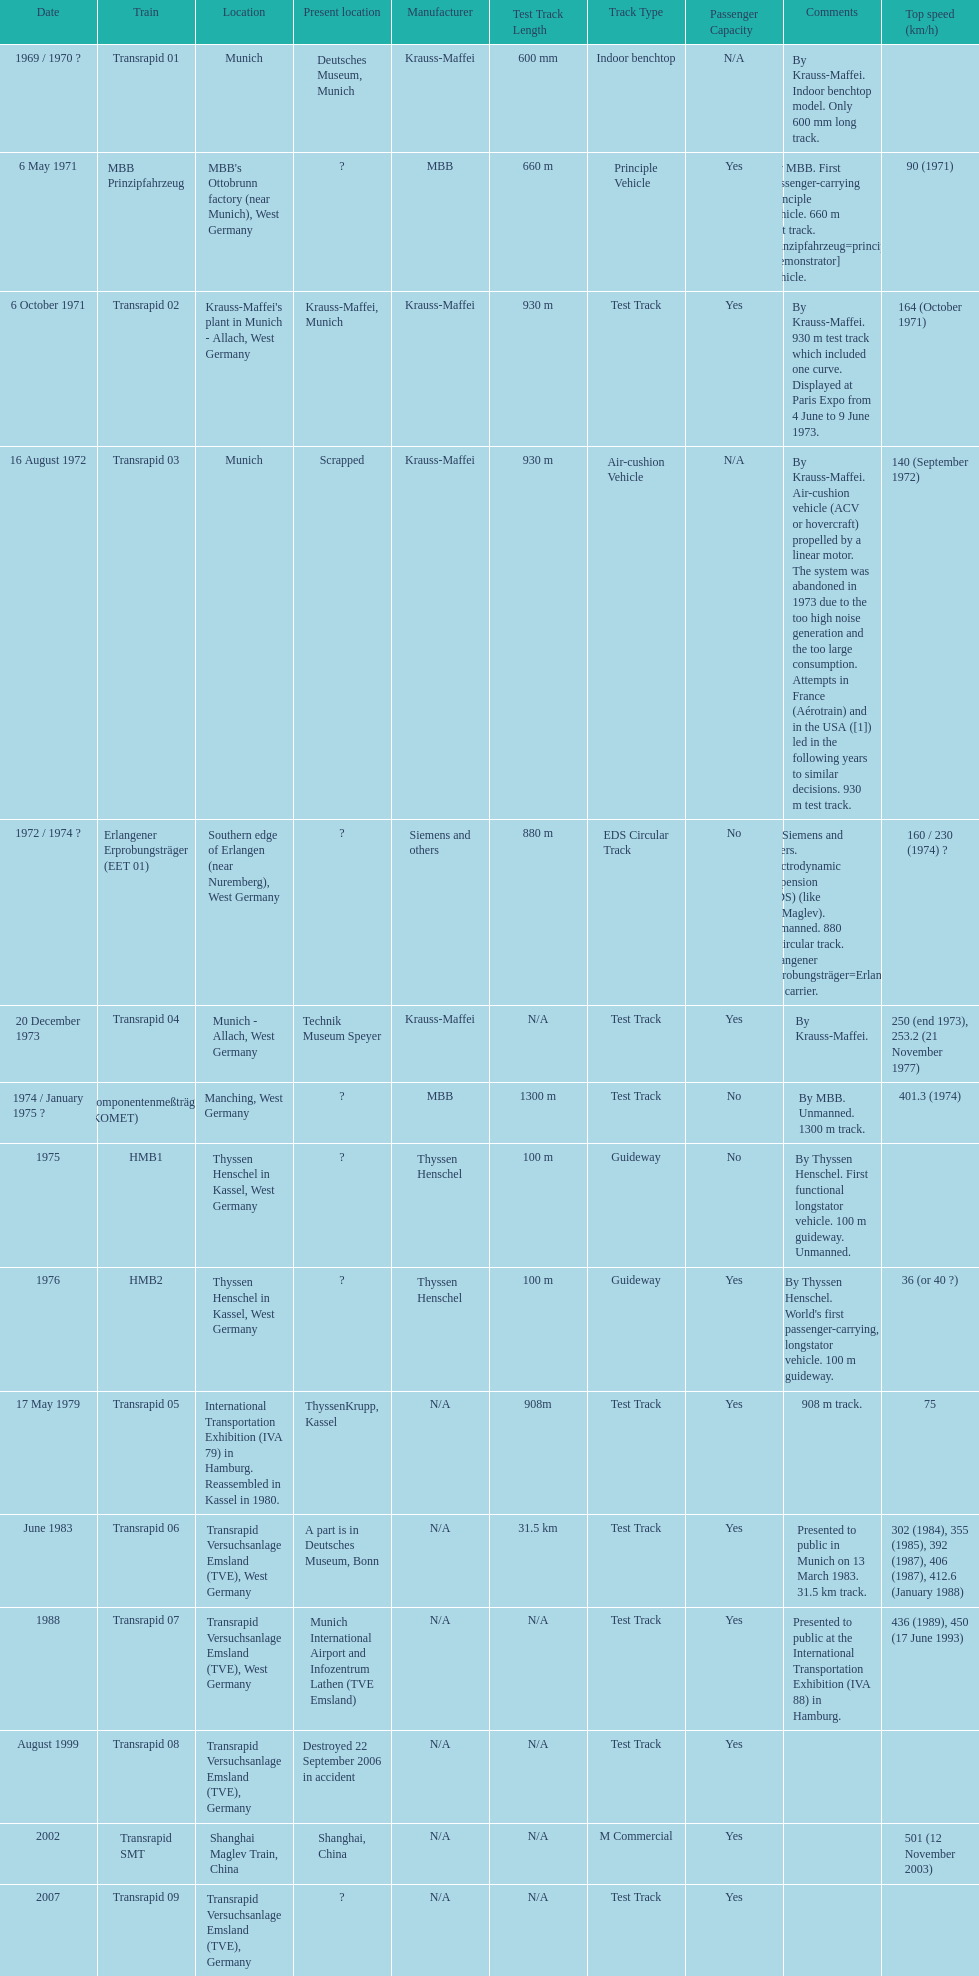Which trains had a top speed listed? MBB Prinzipfahrzeug, Transrapid 02, Transrapid 03, Erlangener Erprobungsträger (EET 01), Transrapid 04, Komponentenmeßträger (KOMET), HMB2, Transrapid 05, Transrapid 06, Transrapid 07, Transrapid SMT. Which ones list munich as a location? MBB Prinzipfahrzeug, Transrapid 02, Transrapid 03. Of these which ones present location is known? Transrapid 02, Transrapid 03. Which of those is no longer in operation? Transrapid 03. 